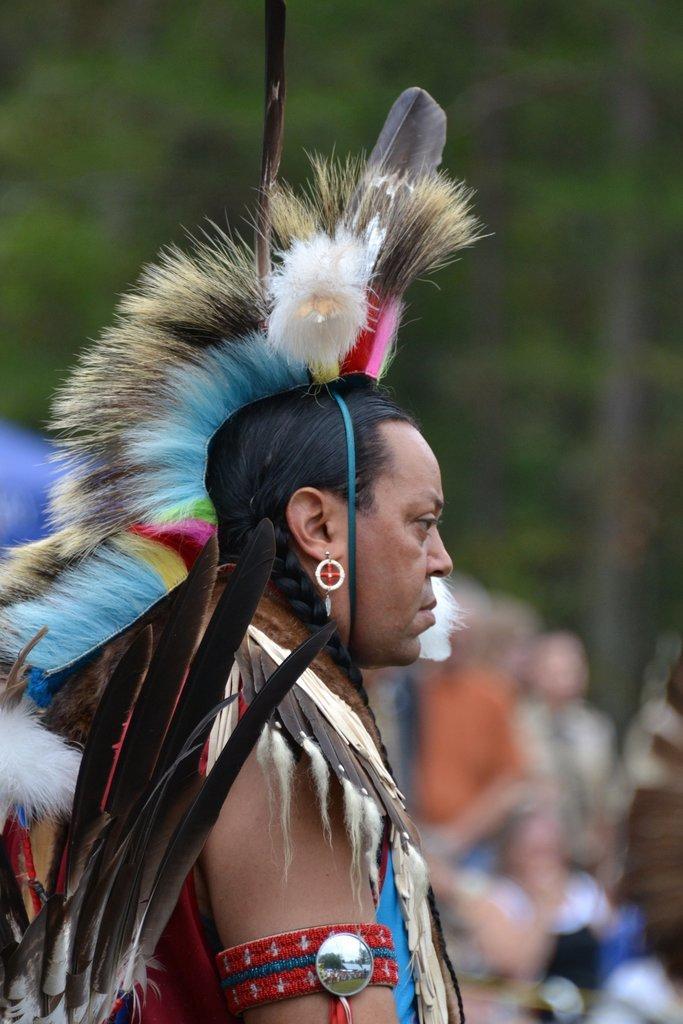Please provide a concise description of this image. In this image in the front there is a man wearing a costume and standing in the front, and the background is blurry. 